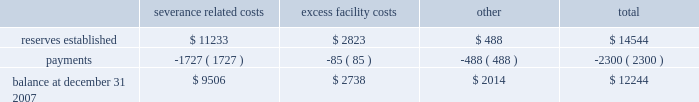Lkq corporation and subsidiaries notes to consolidated financial statements ( continued ) note 8 .
Restructuring and integration costs ( continued ) levels and the closure of excess facilities .
To the extent these restructuring activities are associated with keystone operations , they are being accounted for in accordance with eitf issue no .
95-3 , 2018 2018recognition of liabilities in connection with a purchase business combination . 2019 2019 restructuring activities associated with our existing operations are being accounted for in accordance with sfas no .
146 , 2018 2018accounting for costs associated with exit or disposal activities . 2019 2019 in connection with the keystone restructuring activities , as part of the cost of the acquisition , we established reserves as detailed below .
In accordance with eitf issue no .
95-3 , we intend to finalize our restructuring plans no later than one year from the date of our acquisition of keystone .
Upon finalization of restructuring plans or settlement of obligations for less than the expected amount , any excess reserves will be reversed with a corresponding decrease in goodwill .
Accrued acquisition expenses are included in other accrued expenses in the accompanying consolidated balance sheets .
The changes in accrued acquisition expenses directly related to the keystone acquisition during 2007 are as follows ( in thousands ) : severance excess related costs facility costs other total .
Restructuring and integration costs associated with our existing operations are included in restructuring expenses on the accompanying consolidated statements of income .
Note 9 .
Related party transactions we sublease a portion of our corporate office space to an entity owned by the son of one of our principal stockholders for a pro rata percentage of the rent that we are charged .
The total amounts received from this entity were approximately $ 54000 , $ 70000 and $ 49000 during the years ended december 31 , 2007 , 2006 and 2005 , respectively .
We also paid this entity approximately $ 0.4 million during 2007 for consulting fees incurred in connection with our new secured debt facility .
A corporation owned by our chairman of the board , who is also one of our principal stockholders , owns private aircraft that we use from time to time for business trips .
We reimburse this corporation for out-of-pocket and other related flight expenses , as well as for other direct expenses incurred .
The total amounts paid to this corporation were approximately $ 102000 , $ 6400 and $ 122000 during each of the years ended december 31 , 2007 , 2006 and 2005 , respectively .
In connection with the acquisitions of several businesses , we entered into agreements with several sellers of those businesses , who became stockholders as a result of those acquisitions , for the lease of certain properties used in our operations .
Typical lease terms include an initial term of five years , with three five-year renewal options and purchase options at various times throughout the lease periods .
We also maintain the right of first refusal concerning the sale of the leased property .
Lease payments to a principal stockholder who became an officer of the company after the acquisition of his business were approximately $ 0.8 million during each of the years ended december 31 , 2007 , 2006 and 2005 , respectively. .
What was the average we sublease rental income from 2005 to 2007? 
Computations: (((49000 + (54000 + 70000)) + 3) / 2)
Answer: 86501.5. 